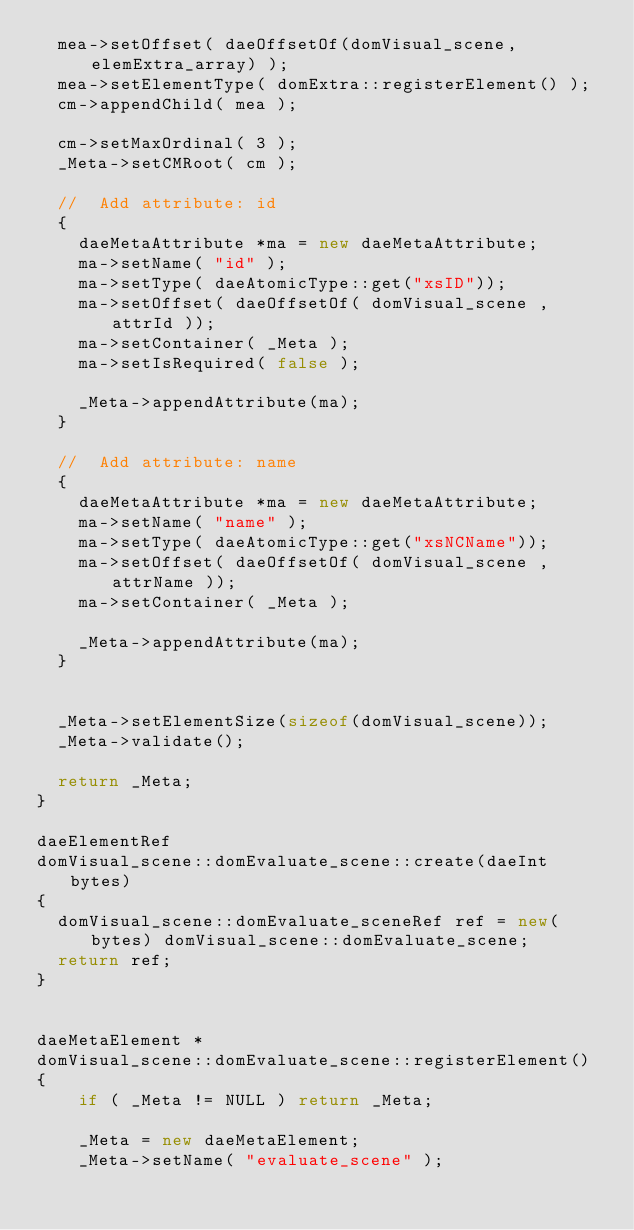<code> <loc_0><loc_0><loc_500><loc_500><_C++_>	mea->setOffset( daeOffsetOf(domVisual_scene,elemExtra_array) );
	mea->setElementType( domExtra::registerElement() );
	cm->appendChild( mea );
	
	cm->setMaxOrdinal( 3 );
	_Meta->setCMRoot( cm );	

	//	Add attribute: id
 	{
		daeMetaAttribute *ma = new daeMetaAttribute;
		ma->setName( "id" );
		ma->setType( daeAtomicType::get("xsID"));
		ma->setOffset( daeOffsetOf( domVisual_scene , attrId ));
		ma->setContainer( _Meta );
		ma->setIsRequired( false );
	
		_Meta->appendAttribute(ma);
	}

	//	Add attribute: name
 	{
		daeMetaAttribute *ma = new daeMetaAttribute;
		ma->setName( "name" );
		ma->setType( daeAtomicType::get("xsNCName"));
		ma->setOffset( daeOffsetOf( domVisual_scene , attrName ));
		ma->setContainer( _Meta );
	
		_Meta->appendAttribute(ma);
	}
	
	
	_Meta->setElementSize(sizeof(domVisual_scene));
	_Meta->validate();

	return _Meta;
}

daeElementRef
domVisual_scene::domEvaluate_scene::create(daeInt bytes)
{
	domVisual_scene::domEvaluate_sceneRef ref = new(bytes) domVisual_scene::domEvaluate_scene;
	return ref;
}


daeMetaElement *
domVisual_scene::domEvaluate_scene::registerElement()
{
    if ( _Meta != NULL ) return _Meta;
    
    _Meta = new daeMetaElement;
    _Meta->setName( "evaluate_scene" );</code> 